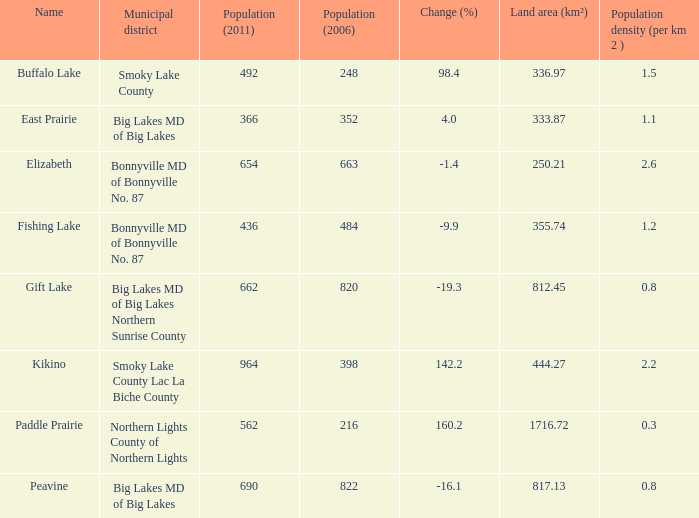What is the population density in Buffalo Lake? 1.5. 